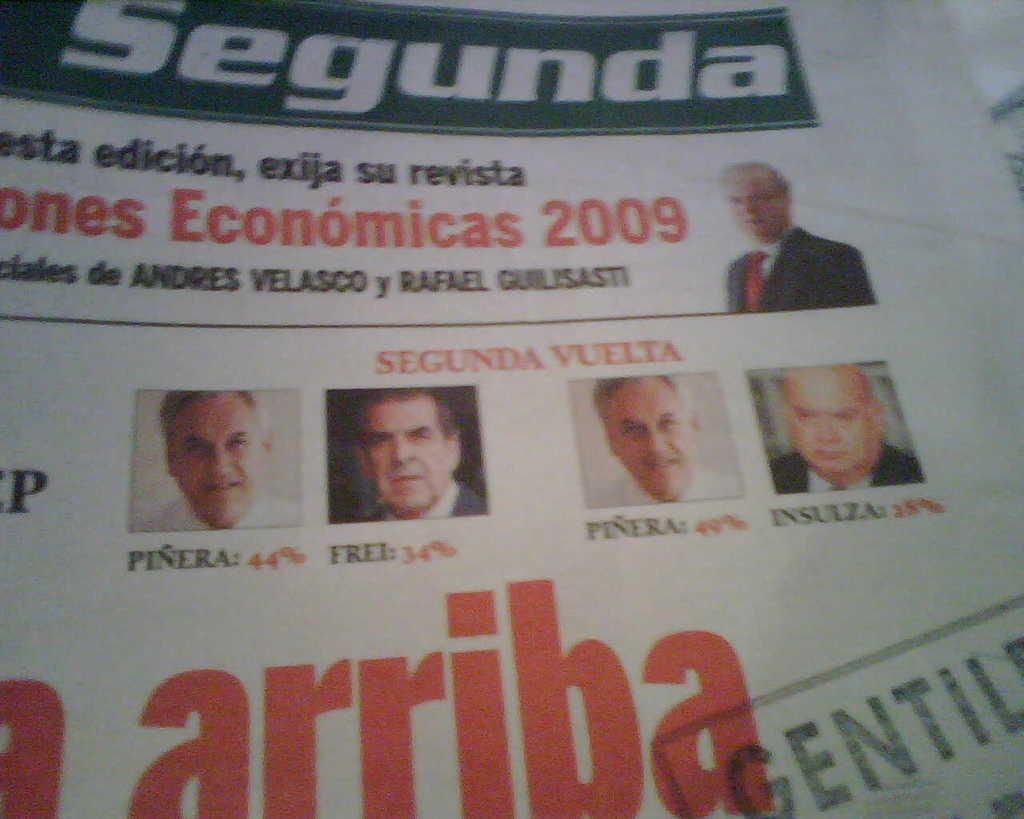Describe this image in one or two sentences. In this image I can see a paper on which I can see pictures of few persons faces. I can see a person wearing white shirt, red tie and black blazer and few words written on the paper. 